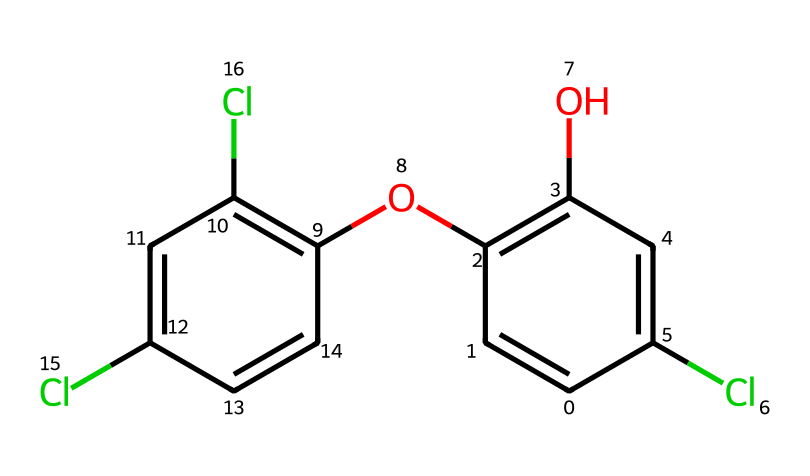How many chlorine atoms are present in the structure? By examining the SMILES representation, we identify the 'Cl' within the structure, which indicates chlorine atoms. There are three occurrences of 'Cl'.
Answer: three What is the functional group indicated by the 'O' in the structure? The 'O' in the SMILES representation corresponds to an oxygen atom, which is part of an ether or alcohol functional group depending on its bonding. Here it indicates the presence of an ether bond as well as an alcohol group.
Answer: alcohol What is the total number of carbon atoms in the structure? The SMILES representation shows multiple 'C' for carbon atoms, counting all 'C' in the sequence gives us a total of 12 carbon atoms present in the compound.
Answer: twelve Identify whether this compound is an aromatic compound. The structure contains carbon atoms that are arranged in a conjugated cyclic manner with alternating double bonds, which is a characteristic of aromatic compounds.
Answer: yes Does this compound exhibit symmetry in its structure? Looking at the arrangement of substituents and the overall shape, the compound displays a certain level of symmetry, particularly due to the presence of two similar aromatic rings.
Answer: yes How many hydroxyl groups are in the structure? By reviewing the structure, we see there is one 'O' that connects to the carbon in a way indicating it's a hydroxyl group (C-OH), which makes for one hydroxyl group.
Answer: one 